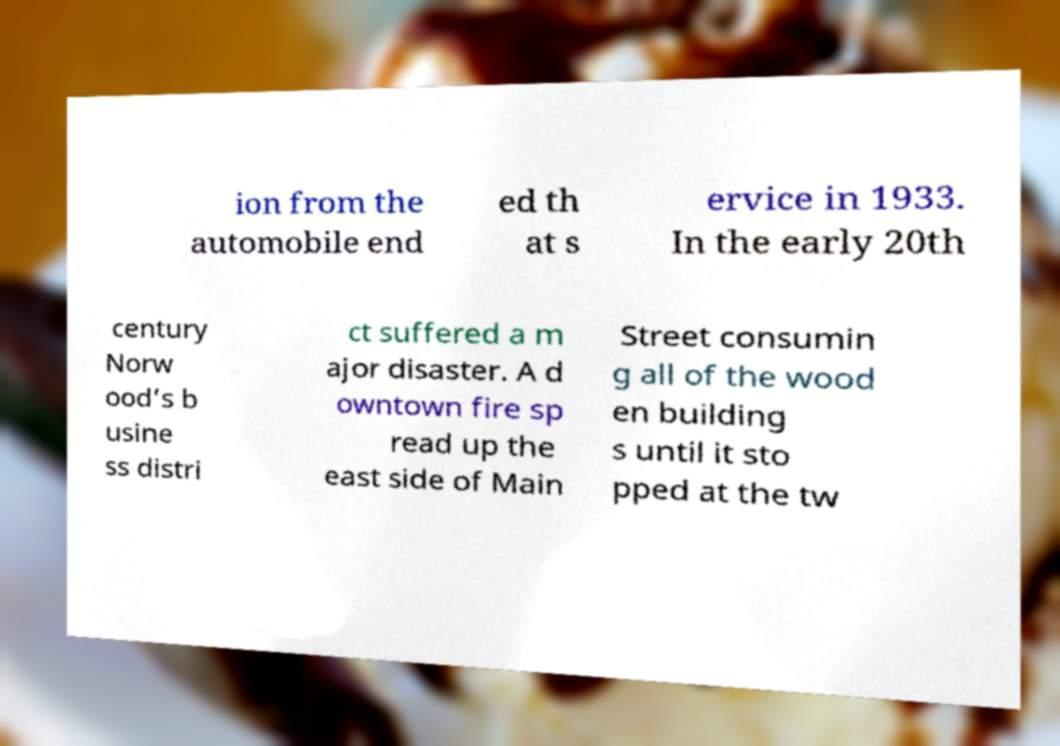Could you extract and type out the text from this image? ion from the automobile end ed th at s ervice in 1933. In the early 20th century Norw ood’s b usine ss distri ct suffered a m ajor disaster. A d owntown fire sp read up the east side of Main Street consumin g all of the wood en building s until it sto pped at the tw 